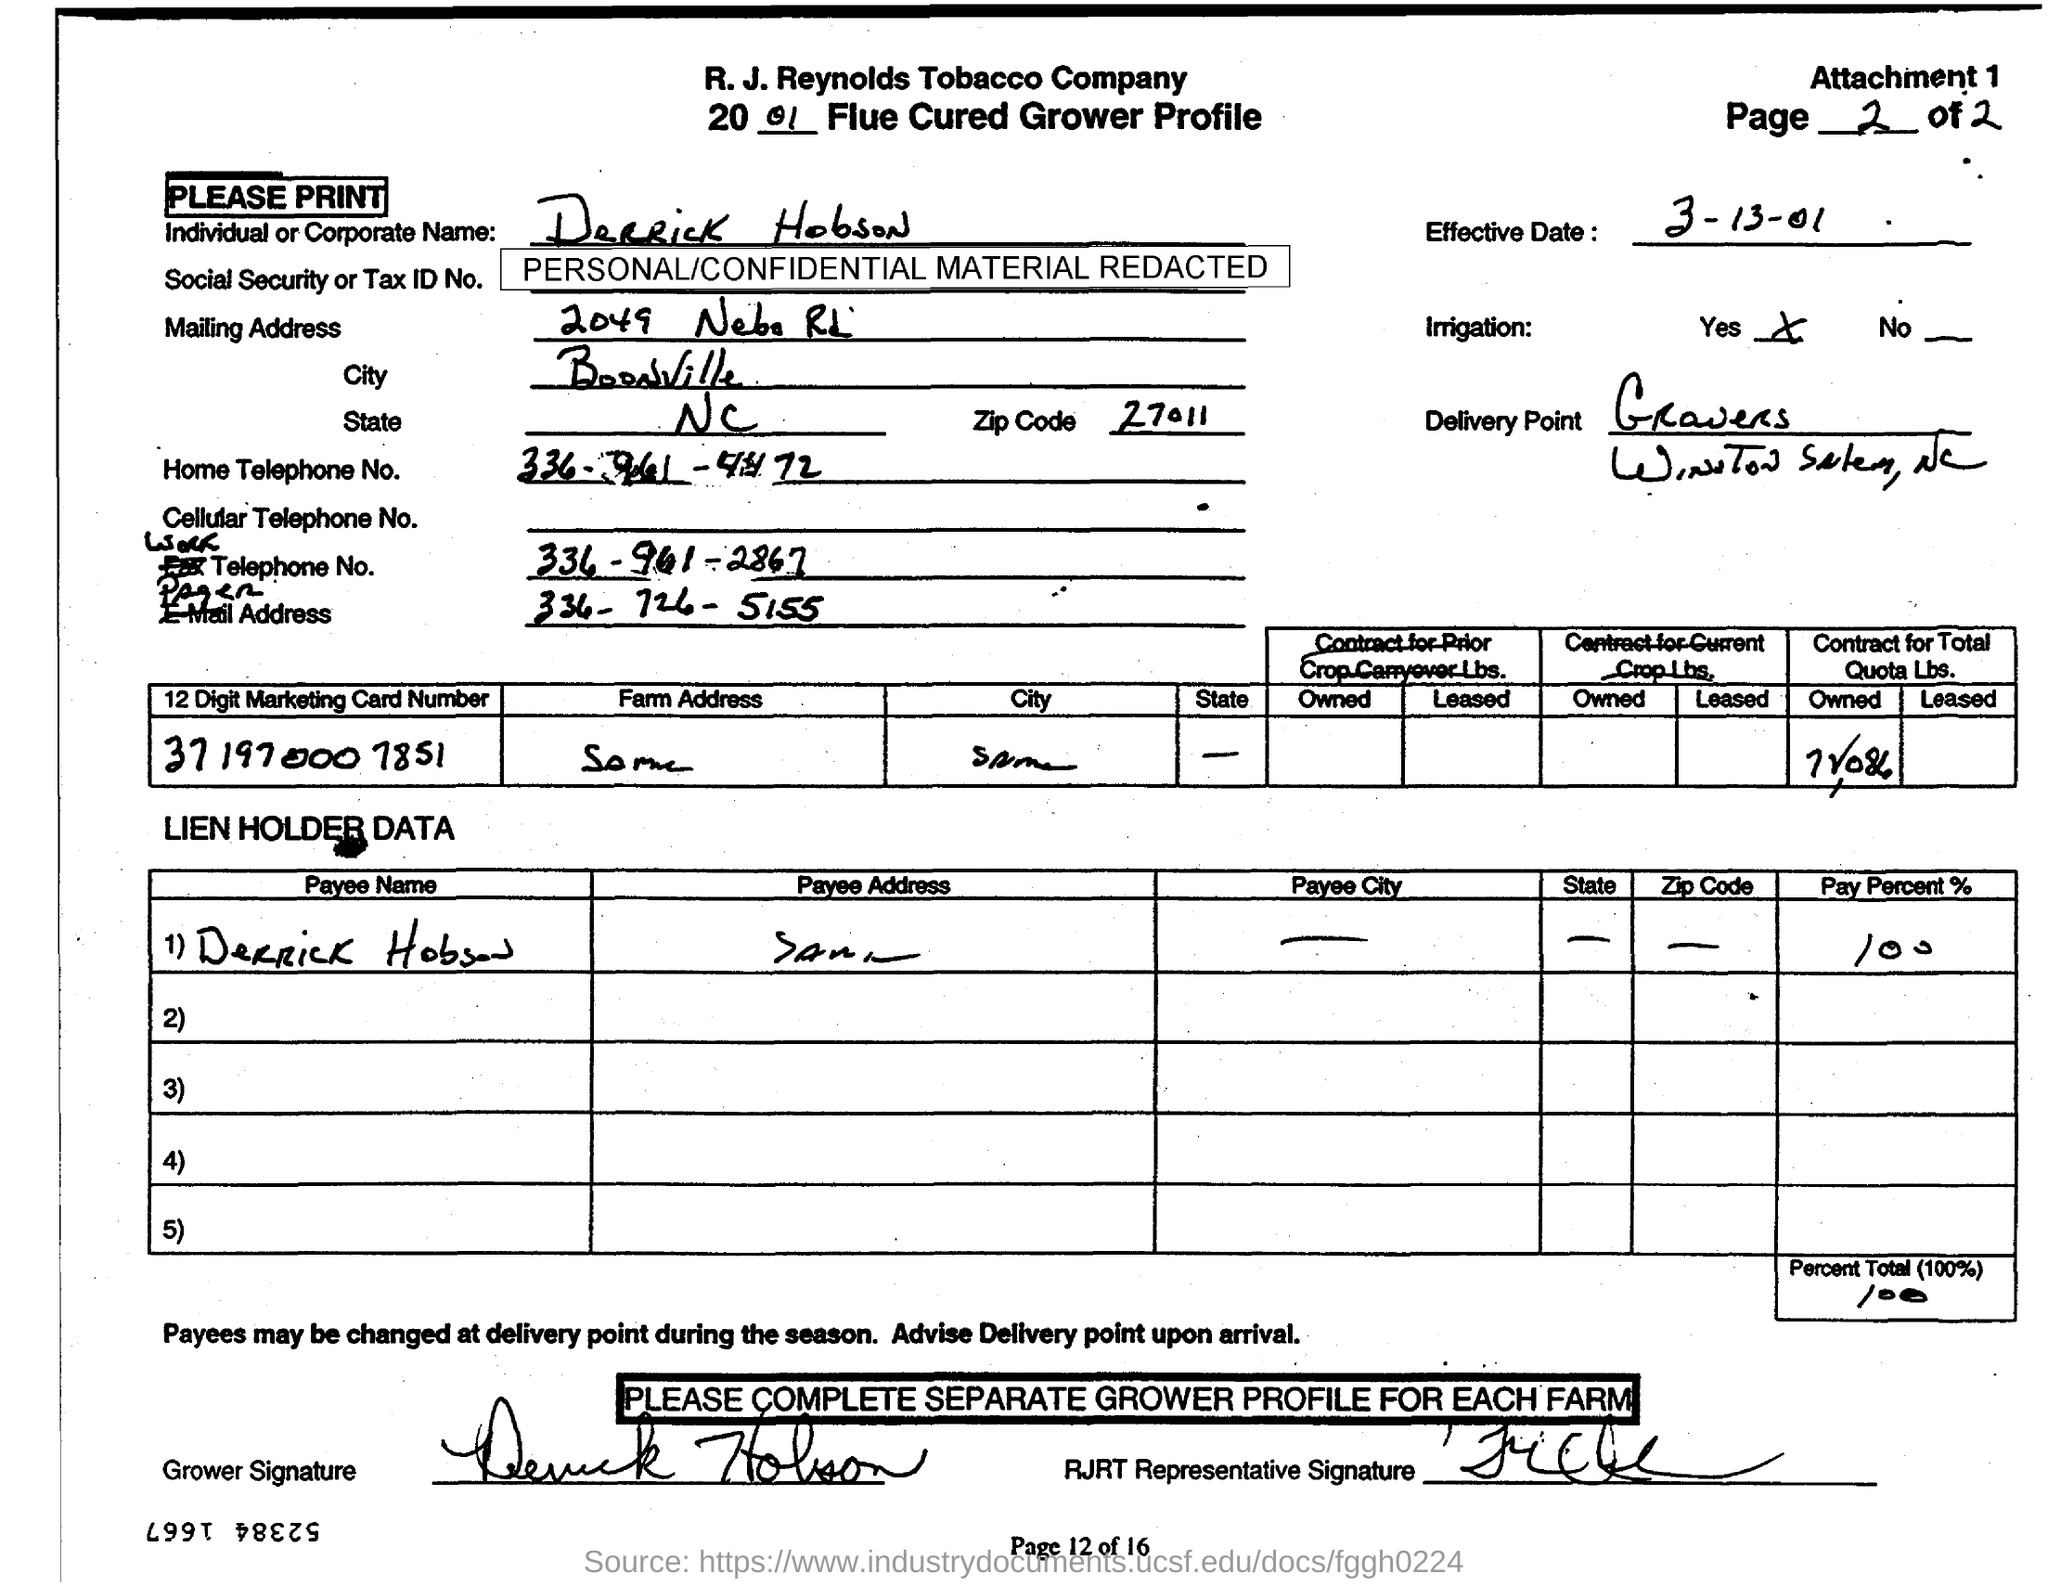Indicate a few pertinent items in this graphic. This document belongs to the year 2001. The name of the individual or corporate entity is Derrick Hobson. The effective date mentioned in the document is 3-13-01. The city mentioned in the mailing address is Boonville. 